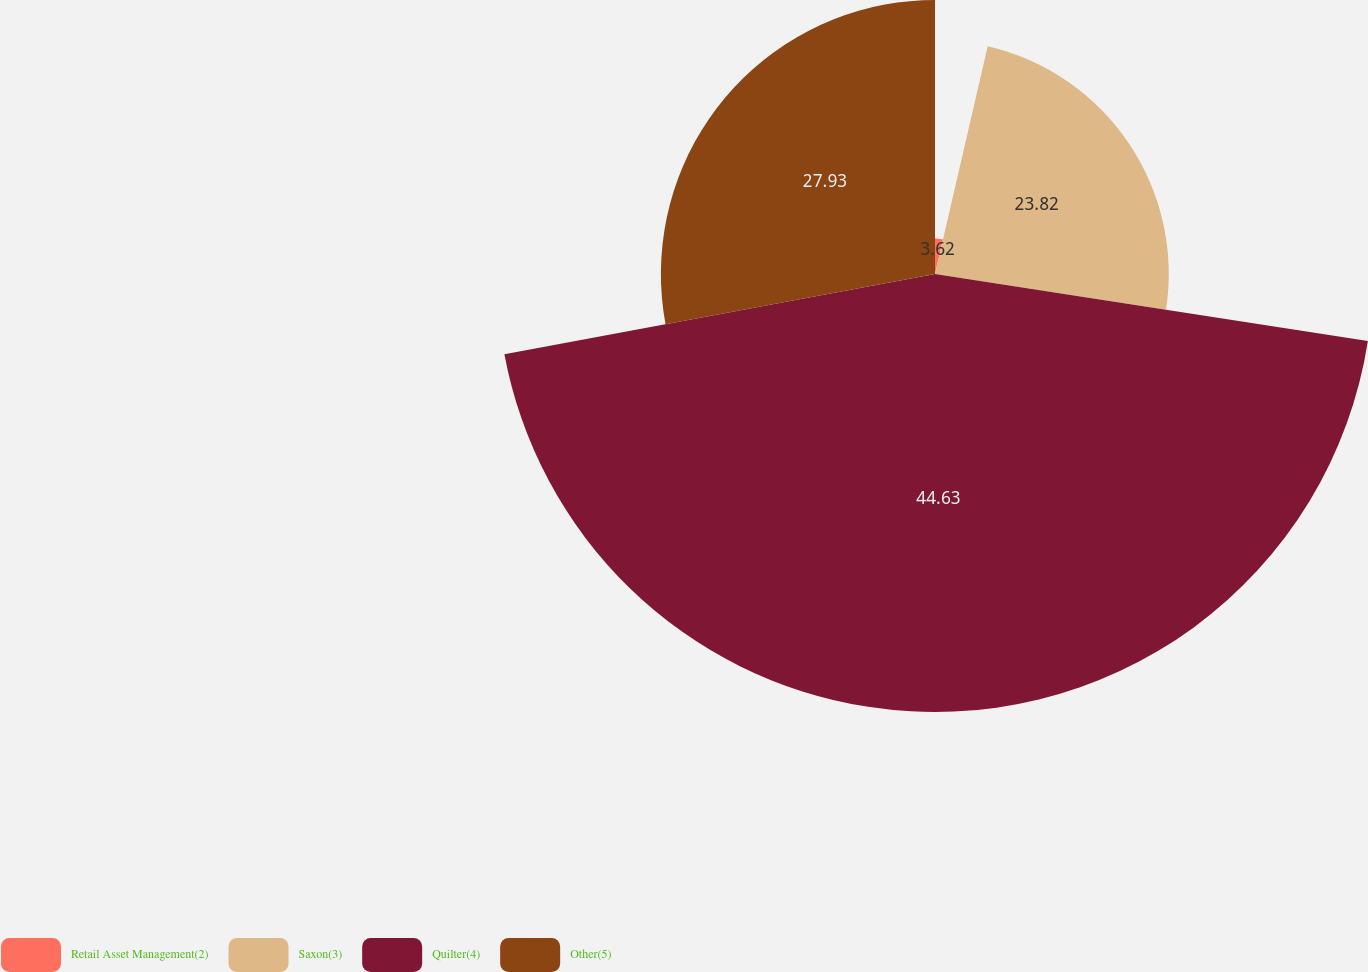<chart> <loc_0><loc_0><loc_500><loc_500><pie_chart><fcel>Retail Asset Management(2)<fcel>Saxon(3)<fcel>Quilter(4)<fcel>Other(5)<nl><fcel>3.62%<fcel>23.82%<fcel>44.63%<fcel>27.93%<nl></chart> 